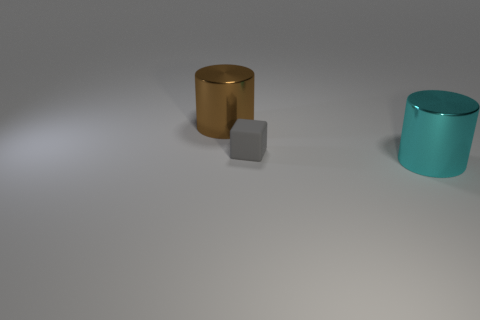Is there any other thing that is the same size as the gray cube?
Make the answer very short. No. What number of objects are either purple cylinders or gray cubes to the right of the large brown cylinder?
Your answer should be very brief. 1. Are there any small gray rubber things?
Offer a very short reply. Yes. What size is the rubber cube that is behind the metal object in front of the tiny matte thing?
Offer a terse response. Small. Is there a tiny blue cylinder made of the same material as the small cube?
Offer a terse response. No. There is a cyan cylinder that is the same size as the brown cylinder; what is its material?
Ensure brevity in your answer.  Metal. Is there a tiny rubber thing right of the metal cylinder on the right side of the brown cylinder?
Offer a very short reply. No. Does the big shiny object that is on the left side of the large cyan metallic thing have the same shape as the large object that is right of the large brown cylinder?
Make the answer very short. Yes. Is the material of the thing that is to the left of the tiny gray block the same as the cylinder on the right side of the brown metal object?
Provide a short and direct response. Yes. What is the material of the gray block that is right of the large cylinder that is left of the matte thing?
Your answer should be compact. Rubber. 